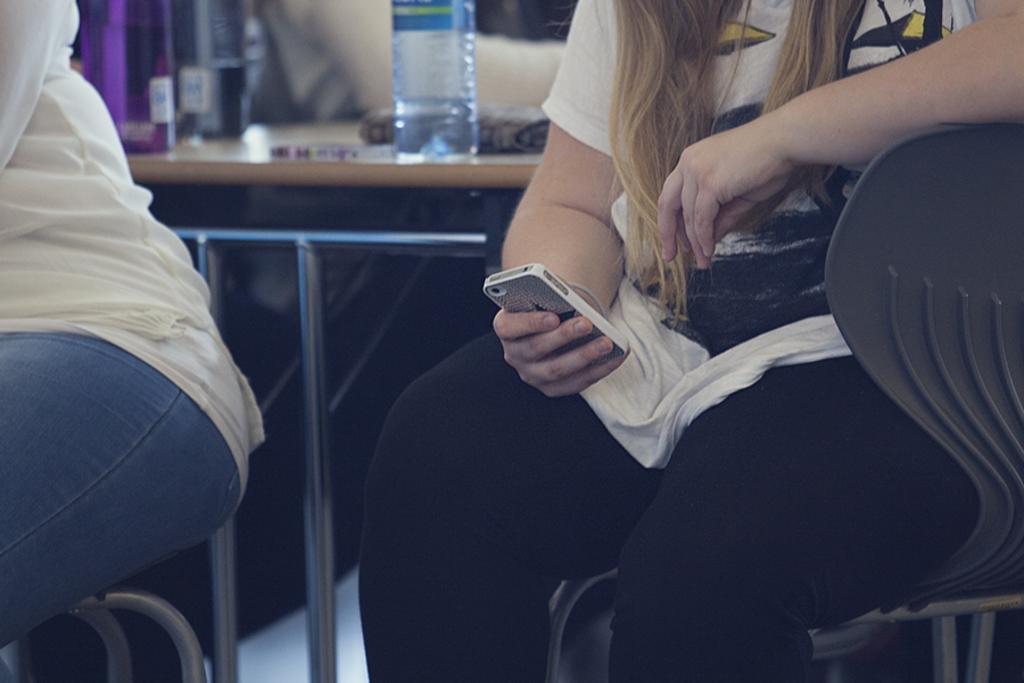How would you summarize this image in a sentence or two? In this image we can see two women wearing white color T-shirt sitting on chairs, on right side of the image there is a woman operating mobile phone and in the background of the image 